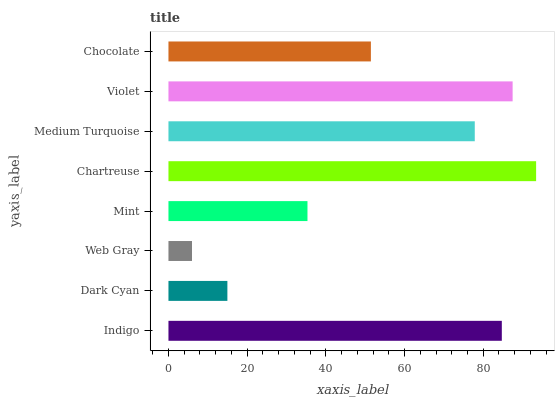Is Web Gray the minimum?
Answer yes or no. Yes. Is Chartreuse the maximum?
Answer yes or no. Yes. Is Dark Cyan the minimum?
Answer yes or no. No. Is Dark Cyan the maximum?
Answer yes or no. No. Is Indigo greater than Dark Cyan?
Answer yes or no. Yes. Is Dark Cyan less than Indigo?
Answer yes or no. Yes. Is Dark Cyan greater than Indigo?
Answer yes or no. No. Is Indigo less than Dark Cyan?
Answer yes or no. No. Is Medium Turquoise the high median?
Answer yes or no. Yes. Is Chocolate the low median?
Answer yes or no. Yes. Is Violet the high median?
Answer yes or no. No. Is Violet the low median?
Answer yes or no. No. 